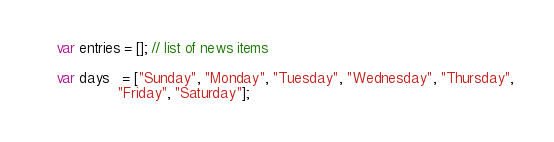<code> <loc_0><loc_0><loc_500><loc_500><_JavaScript_>var entries = []; // list of news items

var days   = ["Sunday", "Monday", "Tuesday", "Wednesday", "Thursday",
              "Friday", "Saturday"];</code> 